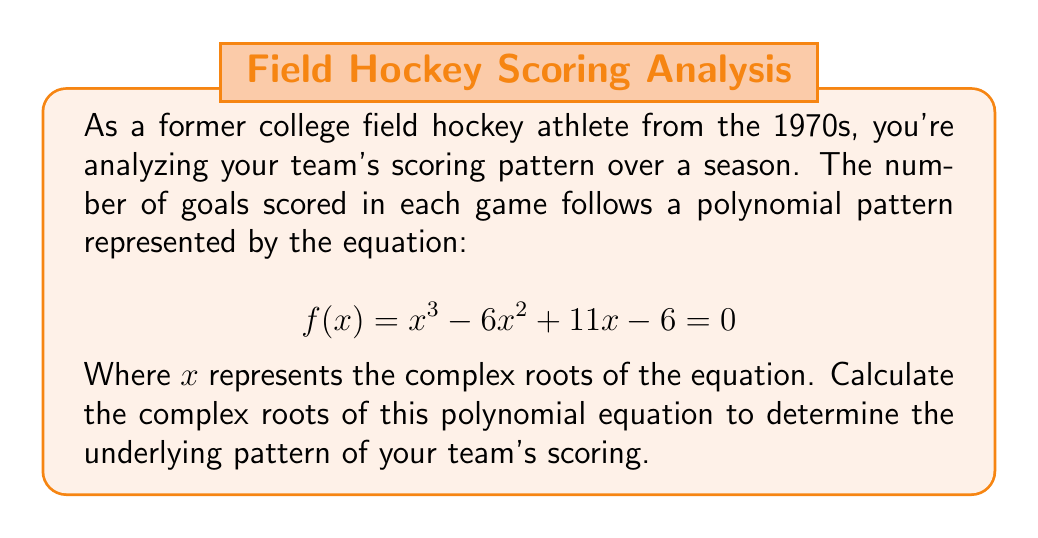Can you solve this math problem? To find the complex roots of the polynomial equation, we'll use the following steps:

1) First, we can factor out the common factor:
   $$ f(x) = (x - 1)(x^2 - 5x + 6) = 0 $$

2) We can see that $x = 1$ is one root. For the quadratic factor, we'll use the quadratic formula:
   $$ x = \frac{-b \pm \sqrt{b^2 - 4ac}}{2a} $$
   Where $a = 1$, $b = -5$, and $c = 6$

3) Substituting these values:
   $$ x = \frac{5 \pm \sqrt{25 - 24}}{2} = \frac{5 \pm \sqrt{1}}{2} = \frac{5 \pm 1}{2} $$

4) This gives us two more roots:
   $$ x = \frac{5 + 1}{2} = 3 \quad \text{and} \quad x = \frac{5 - 1}{2} = 2 $$

5) Therefore, the three roots of the equation are:
   $$ x_1 = 1, \quad x_2 = 2, \quad x_3 = 3 $$

These real roots indicate that the scoring pattern follows a consistent trend without oscillations, which might represent a steady improvement in scoring performance over the season.
Answer: The complex roots of the polynomial equation are: $x_1 = 1$, $x_2 = 2$, and $x_3 = 3$. 